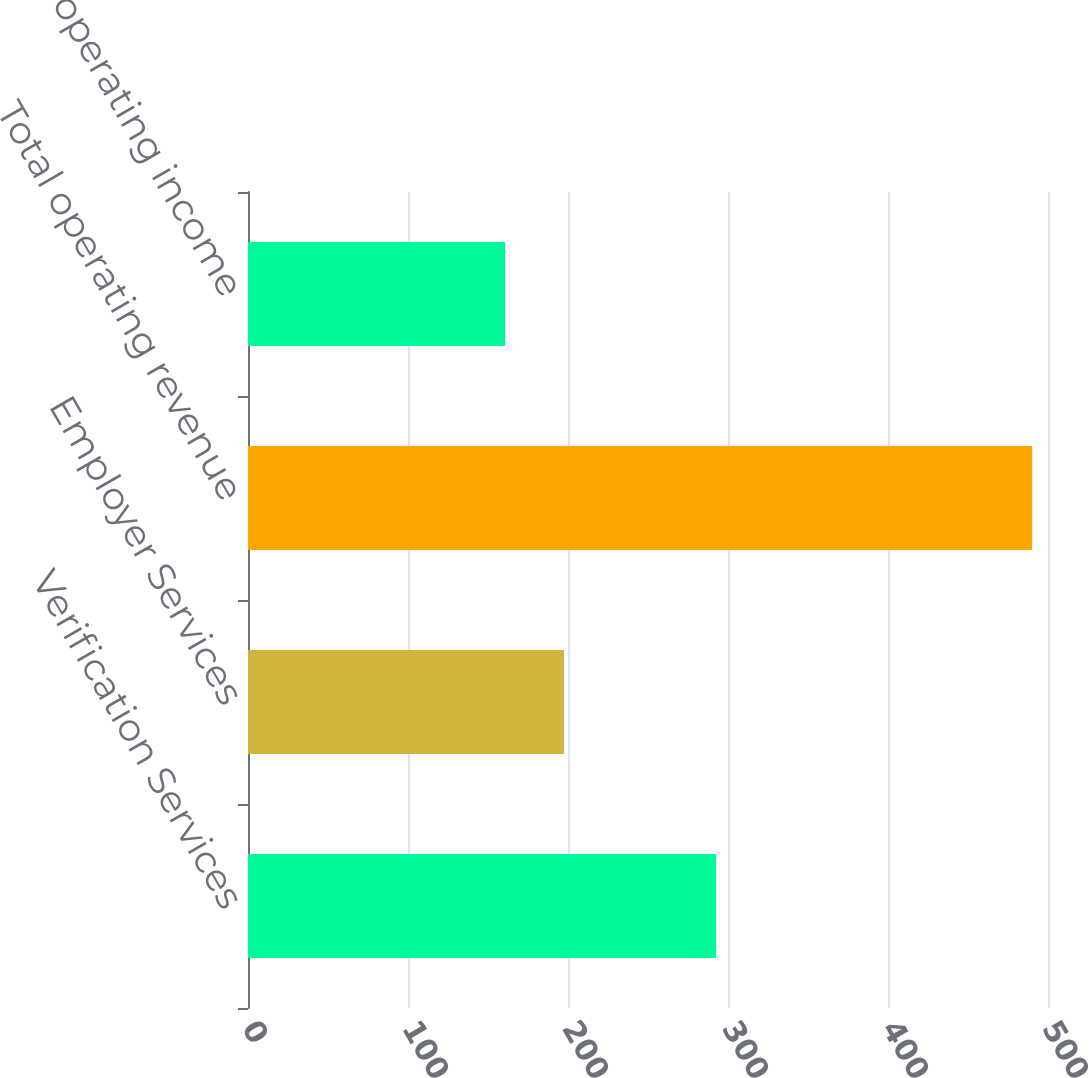<chart> <loc_0><loc_0><loc_500><loc_500><bar_chart><fcel>Verification Services<fcel>Employer Services<fcel>Total operating revenue<fcel>Total operating income<nl><fcel>292.6<fcel>197.5<fcel>490.1<fcel>160.7<nl></chart> 